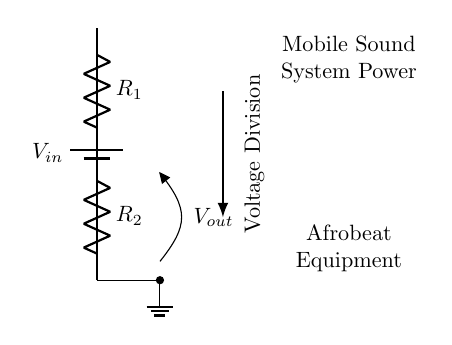What type of component is Vout? Vout is an output voltage taken from the voltage divider in the circuit. It is not a component like a battery or resistor but rather a measurement point in the circuit.
Answer: output voltage What does R1 represent in this circuit? R1 is one of the two resistors in the voltage divider configuration. It divides the input voltage based on its value relative to R2.
Answer: resistor What is the primary function of this circuit? The primary function of this circuit is to divide the input voltage into a lower output voltage for power distribution in the sound system.
Answer: voltage division If R1 is twice the value of R2, how would that affect Vout? If R1 is twice R2, Vout would be one-third of Vin, as the voltage division formula indicates that the output voltage is based on the ratio of R2 to the total resistance.
Answer: one-third of Vin What is the relationship between Vin and Vout in a voltage divider? The relationship is given by the formula Vout equals Vin multiplied by R2 divided by the sum of R1 and R2, showing how input voltage is reduced based on resistor values.
Answer: Vout = Vin * R2 / (R1 + R2) Which component is grounded? The component that is grounded is the bottom connection of R2 leading to the ground symbol, providing a reference point for the voltage output.
Answer: R2 